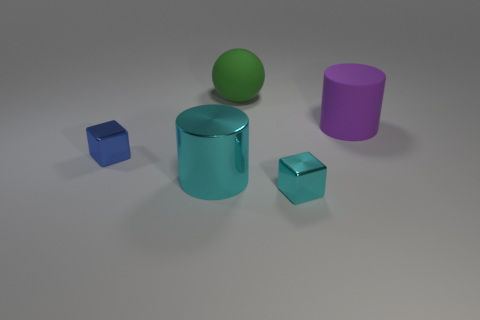What shape is the other big object that is the same material as the blue thing?
Provide a succinct answer. Cylinder. Are there fewer blue objects to the right of the shiny cylinder than tiny metallic cubes that are to the left of the small cyan object?
Offer a very short reply. Yes. What number of small objects are cyan metallic cubes or green spheres?
Ensure brevity in your answer.  1. Is the shape of the object that is in front of the big metallic thing the same as the cyan object left of the big green thing?
Keep it short and to the point. No. What size is the shiny cube that is to the left of the small metallic thing that is in front of the tiny cube to the left of the green rubber sphere?
Make the answer very short. Small. There is a green ball to the left of the rubber cylinder; what size is it?
Ensure brevity in your answer.  Large. What is the cylinder that is in front of the purple matte thing made of?
Give a very brief answer. Metal. How many cyan things are either big matte spheres or big shiny cylinders?
Provide a short and direct response. 1. Do the large cyan cylinder and the small thing that is on the left side of the large sphere have the same material?
Your response must be concise. Yes. Are there an equal number of small shiny cubes that are behind the large purple thing and small blue shiny blocks that are on the left side of the small blue object?
Offer a terse response. Yes. 